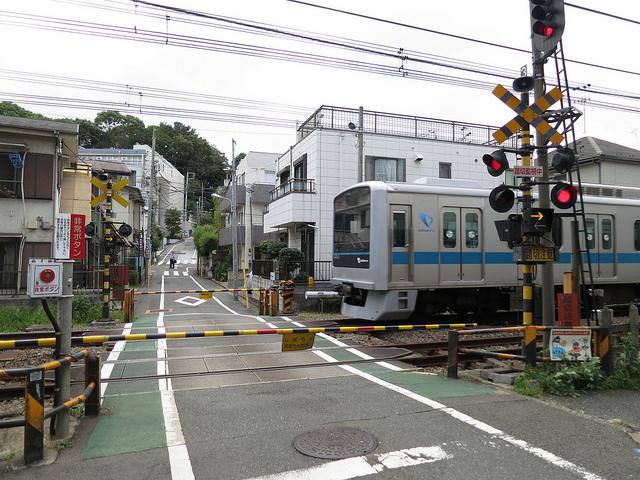What color is the diamond shape on the ground?
Answer briefly. White. Why are the train track barricades there?
Keep it brief. To stop cars. Is the train passing?
Short answer required. Yes. 